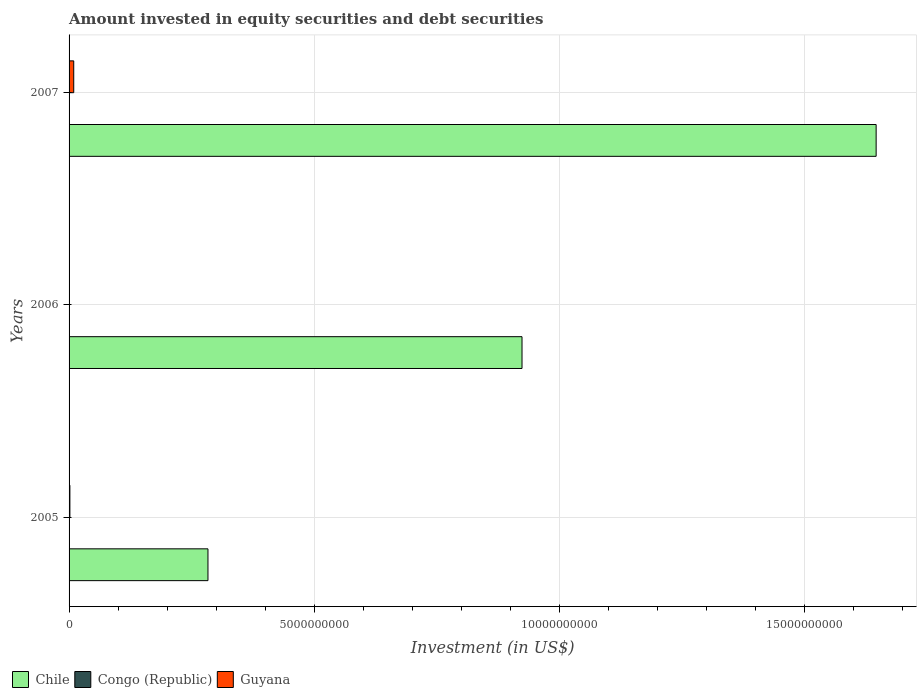Are the number of bars per tick equal to the number of legend labels?
Your response must be concise. Yes. How many bars are there on the 2nd tick from the bottom?
Offer a very short reply. 3. What is the amount invested in equity securities and debt securities in Guyana in 2007?
Provide a succinct answer. 9.51e+07. Across all years, what is the maximum amount invested in equity securities and debt securities in Congo (Republic)?
Your response must be concise. 1.46e+06. Across all years, what is the minimum amount invested in equity securities and debt securities in Guyana?
Provide a succinct answer. 4.10e+06. In which year was the amount invested in equity securities and debt securities in Chile maximum?
Provide a succinct answer. 2007. In which year was the amount invested in equity securities and debt securities in Guyana minimum?
Make the answer very short. 2006. What is the total amount invested in equity securities and debt securities in Chile in the graph?
Offer a very short reply. 2.85e+1. What is the difference between the amount invested in equity securities and debt securities in Guyana in 2006 and that in 2007?
Keep it short and to the point. -9.10e+07. What is the difference between the amount invested in equity securities and debt securities in Guyana in 2006 and the amount invested in equity securities and debt securities in Congo (Republic) in 2005?
Your answer should be compact. 2.96e+06. What is the average amount invested in equity securities and debt securities in Congo (Republic) per year?
Your response must be concise. 1.31e+06. In the year 2007, what is the difference between the amount invested in equity securities and debt securities in Guyana and amount invested in equity securities and debt securities in Chile?
Offer a terse response. -1.64e+1. What is the ratio of the amount invested in equity securities and debt securities in Guyana in 2006 to that in 2007?
Your answer should be very brief. 0.04. Is the amount invested in equity securities and debt securities in Guyana in 2005 less than that in 2006?
Give a very brief answer. No. What is the difference between the highest and the second highest amount invested in equity securities and debt securities in Chile?
Provide a succinct answer. 7.22e+09. What is the difference between the highest and the lowest amount invested in equity securities and debt securities in Guyana?
Offer a terse response. 9.10e+07. Is the sum of the amount invested in equity securities and debt securities in Chile in 2005 and 2007 greater than the maximum amount invested in equity securities and debt securities in Guyana across all years?
Keep it short and to the point. Yes. What does the 2nd bar from the top in 2006 represents?
Your answer should be compact. Congo (Republic). How many years are there in the graph?
Make the answer very short. 3. What is the difference between two consecutive major ticks on the X-axis?
Ensure brevity in your answer.  5.00e+09. Are the values on the major ticks of X-axis written in scientific E-notation?
Offer a terse response. No. Does the graph contain any zero values?
Offer a terse response. No. What is the title of the graph?
Offer a terse response. Amount invested in equity securities and debt securities. What is the label or title of the X-axis?
Your answer should be compact. Investment (in US$). What is the Investment (in US$) of Chile in 2005?
Offer a terse response. 2.83e+09. What is the Investment (in US$) in Congo (Republic) in 2005?
Your response must be concise. 1.14e+06. What is the Investment (in US$) in Guyana in 2005?
Provide a short and direct response. 1.68e+07. What is the Investment (in US$) in Chile in 2006?
Give a very brief answer. 9.24e+09. What is the Investment (in US$) of Congo (Republic) in 2006?
Offer a very short reply. 1.34e+06. What is the Investment (in US$) of Guyana in 2006?
Provide a short and direct response. 4.10e+06. What is the Investment (in US$) in Chile in 2007?
Offer a terse response. 1.65e+1. What is the Investment (in US$) in Congo (Republic) in 2007?
Keep it short and to the point. 1.46e+06. What is the Investment (in US$) of Guyana in 2007?
Provide a short and direct response. 9.51e+07. Across all years, what is the maximum Investment (in US$) of Chile?
Ensure brevity in your answer.  1.65e+1. Across all years, what is the maximum Investment (in US$) in Congo (Republic)?
Provide a short and direct response. 1.46e+06. Across all years, what is the maximum Investment (in US$) of Guyana?
Ensure brevity in your answer.  9.51e+07. Across all years, what is the minimum Investment (in US$) in Chile?
Your answer should be compact. 2.83e+09. Across all years, what is the minimum Investment (in US$) of Congo (Republic)?
Ensure brevity in your answer.  1.14e+06. Across all years, what is the minimum Investment (in US$) in Guyana?
Ensure brevity in your answer.  4.10e+06. What is the total Investment (in US$) of Chile in the graph?
Offer a very short reply. 2.85e+1. What is the total Investment (in US$) in Congo (Republic) in the graph?
Your response must be concise. 3.94e+06. What is the total Investment (in US$) in Guyana in the graph?
Provide a short and direct response. 1.16e+08. What is the difference between the Investment (in US$) of Chile in 2005 and that in 2006?
Make the answer very short. -6.41e+09. What is the difference between the Investment (in US$) in Congo (Republic) in 2005 and that in 2006?
Offer a terse response. -2.01e+05. What is the difference between the Investment (in US$) of Guyana in 2005 and that in 2006?
Your answer should be very brief. 1.27e+07. What is the difference between the Investment (in US$) in Chile in 2005 and that in 2007?
Provide a succinct answer. -1.36e+1. What is the difference between the Investment (in US$) of Congo (Republic) in 2005 and that in 2007?
Give a very brief answer. -3.23e+05. What is the difference between the Investment (in US$) of Guyana in 2005 and that in 2007?
Your answer should be very brief. -7.83e+07. What is the difference between the Investment (in US$) in Chile in 2006 and that in 2007?
Provide a short and direct response. -7.22e+09. What is the difference between the Investment (in US$) in Congo (Republic) in 2006 and that in 2007?
Make the answer very short. -1.22e+05. What is the difference between the Investment (in US$) in Guyana in 2006 and that in 2007?
Provide a succinct answer. -9.10e+07. What is the difference between the Investment (in US$) of Chile in 2005 and the Investment (in US$) of Congo (Republic) in 2006?
Keep it short and to the point. 2.83e+09. What is the difference between the Investment (in US$) of Chile in 2005 and the Investment (in US$) of Guyana in 2006?
Your response must be concise. 2.83e+09. What is the difference between the Investment (in US$) of Congo (Republic) in 2005 and the Investment (in US$) of Guyana in 2006?
Your response must be concise. -2.96e+06. What is the difference between the Investment (in US$) in Chile in 2005 and the Investment (in US$) in Congo (Republic) in 2007?
Your response must be concise. 2.83e+09. What is the difference between the Investment (in US$) of Chile in 2005 and the Investment (in US$) of Guyana in 2007?
Keep it short and to the point. 2.74e+09. What is the difference between the Investment (in US$) of Congo (Republic) in 2005 and the Investment (in US$) of Guyana in 2007?
Your response must be concise. -9.40e+07. What is the difference between the Investment (in US$) of Chile in 2006 and the Investment (in US$) of Congo (Republic) in 2007?
Your answer should be compact. 9.24e+09. What is the difference between the Investment (in US$) of Chile in 2006 and the Investment (in US$) of Guyana in 2007?
Your response must be concise. 9.14e+09. What is the difference between the Investment (in US$) in Congo (Republic) in 2006 and the Investment (in US$) in Guyana in 2007?
Make the answer very short. -9.38e+07. What is the average Investment (in US$) of Chile per year?
Give a very brief answer. 9.51e+09. What is the average Investment (in US$) in Congo (Republic) per year?
Your response must be concise. 1.31e+06. What is the average Investment (in US$) of Guyana per year?
Offer a very short reply. 3.87e+07. In the year 2005, what is the difference between the Investment (in US$) of Chile and Investment (in US$) of Congo (Republic)?
Your answer should be compact. 2.83e+09. In the year 2005, what is the difference between the Investment (in US$) of Chile and Investment (in US$) of Guyana?
Your answer should be compact. 2.82e+09. In the year 2005, what is the difference between the Investment (in US$) in Congo (Republic) and Investment (in US$) in Guyana?
Offer a terse response. -1.57e+07. In the year 2006, what is the difference between the Investment (in US$) of Chile and Investment (in US$) of Congo (Republic)?
Your response must be concise. 9.24e+09. In the year 2006, what is the difference between the Investment (in US$) in Chile and Investment (in US$) in Guyana?
Keep it short and to the point. 9.23e+09. In the year 2006, what is the difference between the Investment (in US$) in Congo (Republic) and Investment (in US$) in Guyana?
Ensure brevity in your answer.  -2.76e+06. In the year 2007, what is the difference between the Investment (in US$) of Chile and Investment (in US$) of Congo (Republic)?
Provide a short and direct response. 1.65e+1. In the year 2007, what is the difference between the Investment (in US$) in Chile and Investment (in US$) in Guyana?
Give a very brief answer. 1.64e+1. In the year 2007, what is the difference between the Investment (in US$) of Congo (Republic) and Investment (in US$) of Guyana?
Give a very brief answer. -9.36e+07. What is the ratio of the Investment (in US$) of Chile in 2005 to that in 2006?
Provide a short and direct response. 0.31. What is the ratio of the Investment (in US$) of Congo (Republic) in 2005 to that in 2006?
Offer a terse response. 0.85. What is the ratio of the Investment (in US$) of Guyana in 2005 to that in 2006?
Your response must be concise. 4.1. What is the ratio of the Investment (in US$) in Chile in 2005 to that in 2007?
Your answer should be compact. 0.17. What is the ratio of the Investment (in US$) of Congo (Republic) in 2005 to that in 2007?
Your answer should be very brief. 0.78. What is the ratio of the Investment (in US$) in Guyana in 2005 to that in 2007?
Offer a terse response. 0.18. What is the ratio of the Investment (in US$) of Chile in 2006 to that in 2007?
Your response must be concise. 0.56. What is the ratio of the Investment (in US$) in Congo (Republic) in 2006 to that in 2007?
Your response must be concise. 0.92. What is the ratio of the Investment (in US$) of Guyana in 2006 to that in 2007?
Keep it short and to the point. 0.04. What is the difference between the highest and the second highest Investment (in US$) of Chile?
Your answer should be compact. 7.22e+09. What is the difference between the highest and the second highest Investment (in US$) in Congo (Republic)?
Give a very brief answer. 1.22e+05. What is the difference between the highest and the second highest Investment (in US$) in Guyana?
Your answer should be very brief. 7.83e+07. What is the difference between the highest and the lowest Investment (in US$) of Chile?
Give a very brief answer. 1.36e+1. What is the difference between the highest and the lowest Investment (in US$) in Congo (Republic)?
Your response must be concise. 3.23e+05. What is the difference between the highest and the lowest Investment (in US$) of Guyana?
Keep it short and to the point. 9.10e+07. 